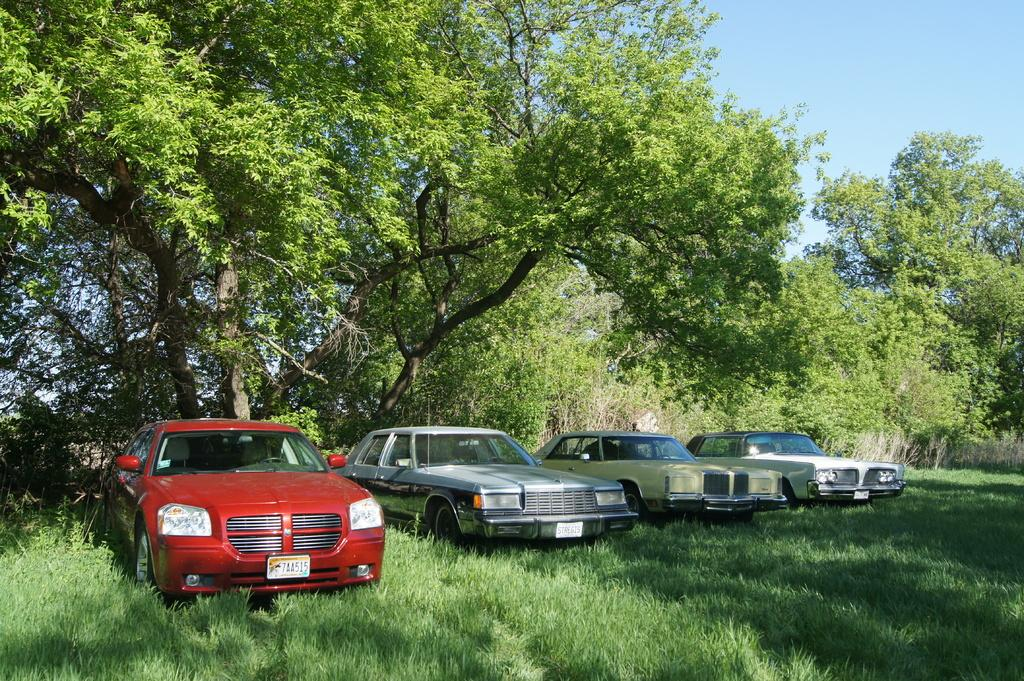How many parked cars can be seen in the image? There are four parked cars in the image. What type of vegetation is present in the image? There are trees with branches and leaves in the image. What is the color of the grass visible in the image? The grass visible in the image is green. What can be seen above the trees and cars in the image? The sky is visible in the image. What type of meat is being grilled in the image? There is no meat or grill present in the image. 